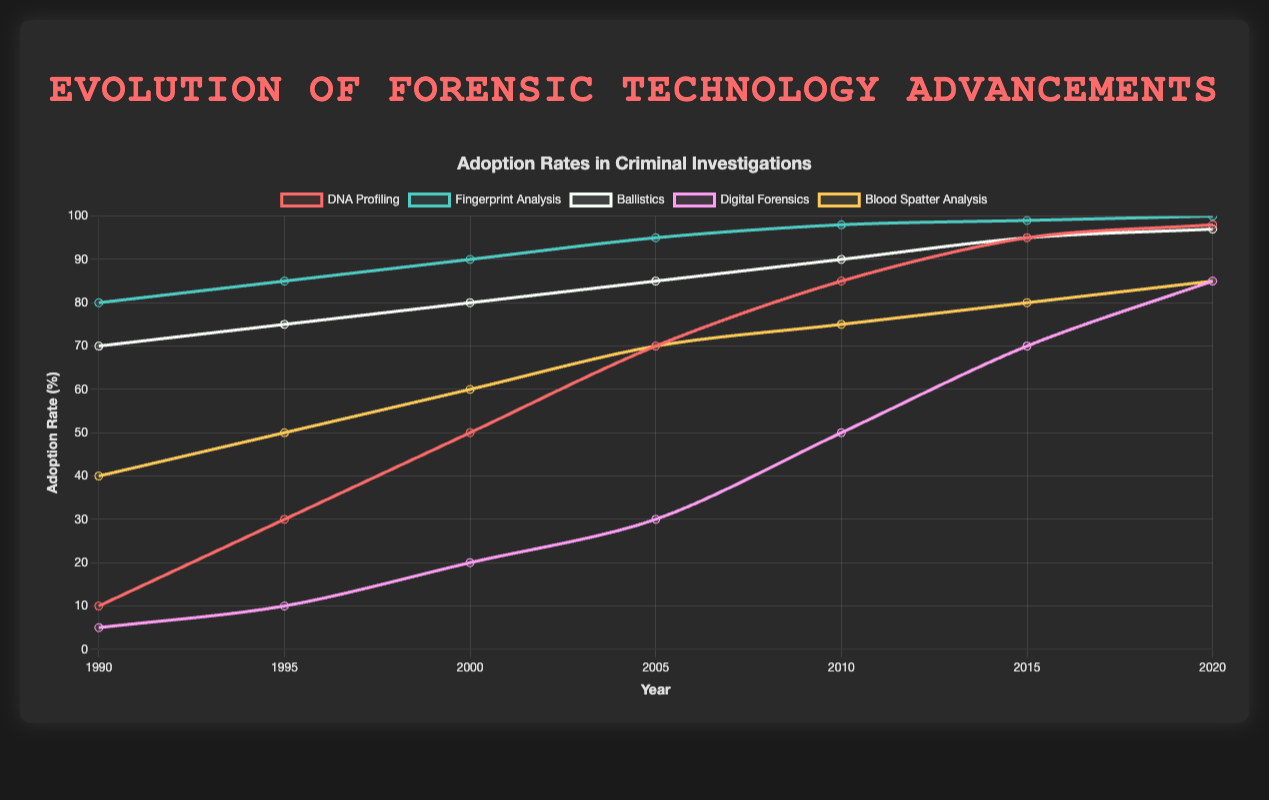Which forensic technology had the highest adoption rate in 1990? By looking at the plot for 1990, we can identify the technology with the highest adoption rate. Fingerprint Analysis has the highest adoption rate of 80%.
Answer: Fingerprint Analysis In which year did DNA Profiling first exceed 50% adoption rate? By observing the DNA Profiling line, we can see that its adoption rate first exceeded 50% in the year 2000.
Answer: 2000 How much did Digital Forensics adoption increase from 2000 to 2010? Digital Forensics had an adoption rate of 20% in 2000 and 50% in 2010. The increase is 50% - 20% = 30%.
Answer: 30% Compare the adoption rates of Ballistics and Digital Forensics in 2020. Which one is higher and by how much? In 2020, Ballistics has an adoption rate of 97% and Digital Forensics has 85%. The difference is 97% - 85% = 12%, with Ballistics being higher.
Answer: Ballistics by 12% Identify the forensic technology that showed the most consistent increase in adoption rate from 1990 to 2020. By examining the slopes of the lines for each technology, DNA Profiling shows the most consistent increase from 10% in 1990 to 98% in 2020.
Answer: DNA Profiling Between 1990 and 2005, which forensic technology had the smallest increase in adoption rate? Calculating the differences: DNA Profiling (70 - 10 = 60), Fingerprint Analysis (95 - 80 = 15), Ballistics (85 - 70 = 15), Digital Forensics (30 - 5 = 25), Blood Spatter Analysis (70 - 40 = 30). Fingerprint Analysis and Ballistics both had the smallest increase of 15%.
Answer: Fingerprint Analysis/Ballistics What is the average adoption rate of Blood Spatter Analysis over the decades presented? The average is calculated by summing the adoption rates and dividing by the number of data points: (40 + 50 + 60 + 70 + 75 + 80 + 85) / 7 = 66.43%.
Answer: 66.43% By how much did the adoption rate of Fingerprint Analysis increase from 1995 to 2020? Fingerprint Analysis increased from 85% in 1995 to 100% in 2020. The increase is 100% - 85% = 15%.
Answer: 15% Which year shows the largest difference between the adoption rates of DNA Profiling and Digital Forensics? Calculate the differences for each year and find the maximum: 1990 (5), 1995 (20), 2000 (30), 2005 (40), 2010 (35), 2015 (25), 2020 (13). The largest difference is 40 in 2005.
Answer: 2005 